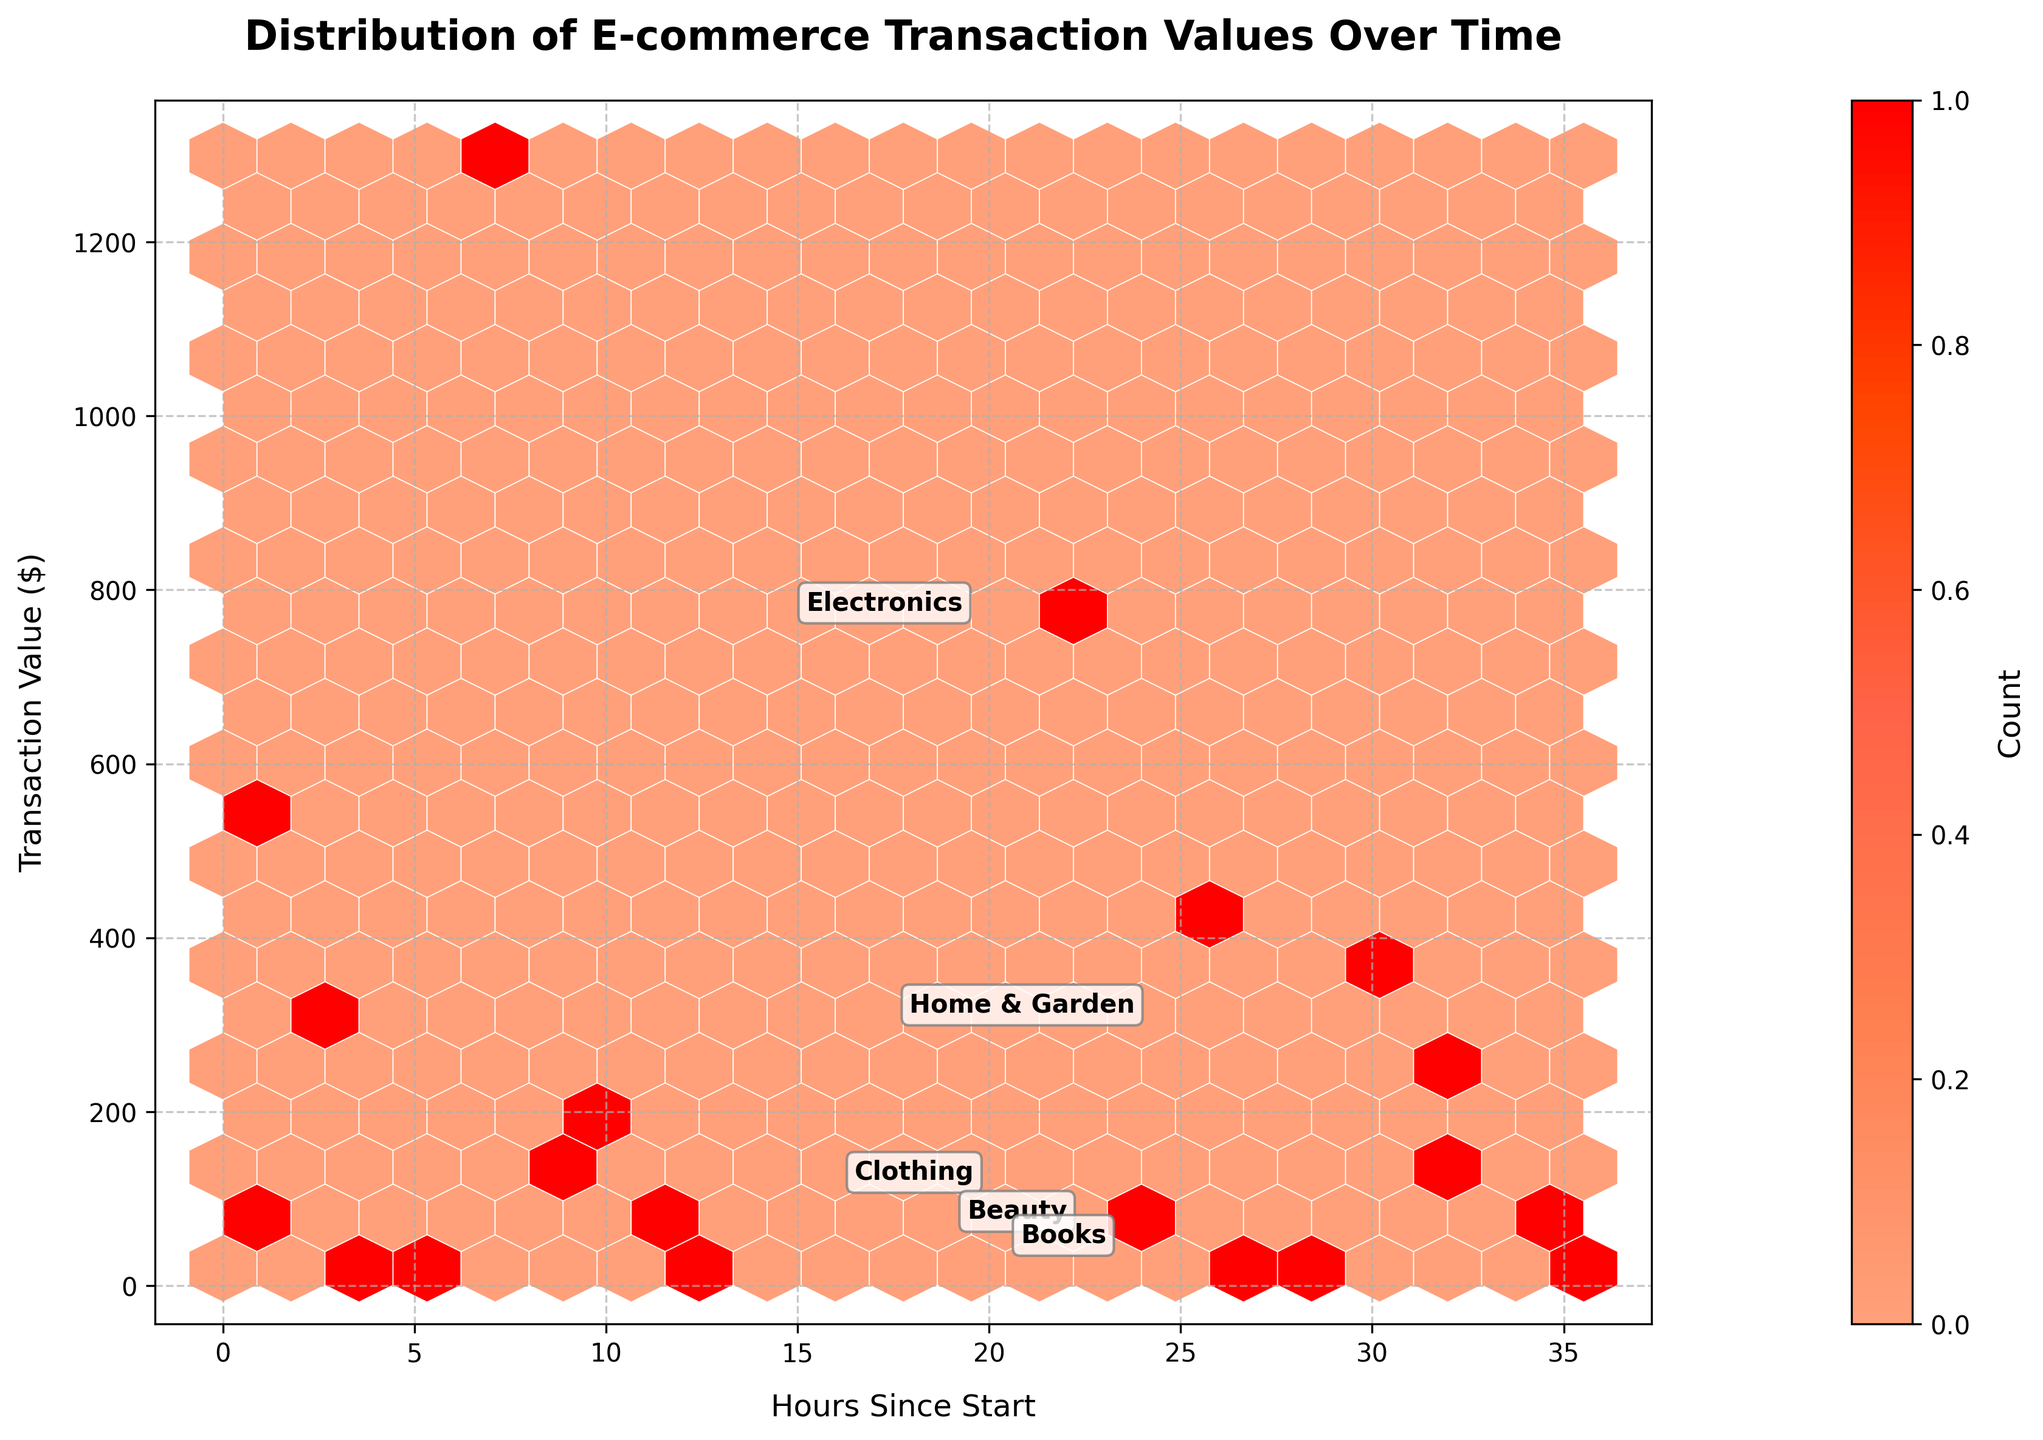What is the title of the plot? The title of the plot is written at the top and describes the main focus of the visualization.
Answer: Distribution of E-commerce Transaction Values Over Time What do the x and y axes represent? The x and y axes have labels that describe what each axis represents. The x-axis represents the 'Hours Since Start', and the y-axis represents the 'Transaction Value ($)'.
Answer: Hours Since Start and Transaction Value ($) How many unique product categories are annotated in the plot? There are distinct labels on the plot indicating different product categories. By counting these labels, we can determine there are five annotations: Electronics, Clothing, Home & Garden, Beauty, and Books.
Answer: 5 Which product category has the highest average transaction value based on its annotation position? By looking at the positions of the annotations and associating them with the y-values, we can determine which category has the highest average transaction value. Electronics is positioned highest, indicating it has the highest average transaction value.
Answer: Electronics Between which hours does the majority of high-value transactions seem to occur? The hexbin plot will have dense regions representing high-count transactions. By observing the cluster of hexagons in the higher y-values, it appears the majority of high-value transactions occur between approximately 7 and 17 hours.
Answer: 7 and 17 hours What does the color intensity in the hexagons represent? The color intensity changes based on the density of data points within each hexagon. A legend or color bar typically indicates that darker or more intense colors represent a higher count of transactions.
Answer: Count of transactions Which product category shows the widest range of transaction values? By comparing the spread of the annotations along the y-axis, we can see which product category spans the largest range. Electronics spans from around $400 to $1300, the widest range.
Answer: Electronics Is the distribution of transaction values more dense at lower or higher values? The density of the hexagons and their color intensity will indicate where most of the transactions occur. Observing the plot, most transactions have lower values, as indicated by the higher density of hexagons in the lower y-value range.
Answer: Lower values Do any product categories have a noticeable cluster of transactions at specific times? If yes, which one(s)? By observing the annotations and positions of dense hexbin clusters, we can identify any specific clustering patterns for each product category. Home & Garden shows such a cluster around 11-12 hours.
Answer: Home & Garden 